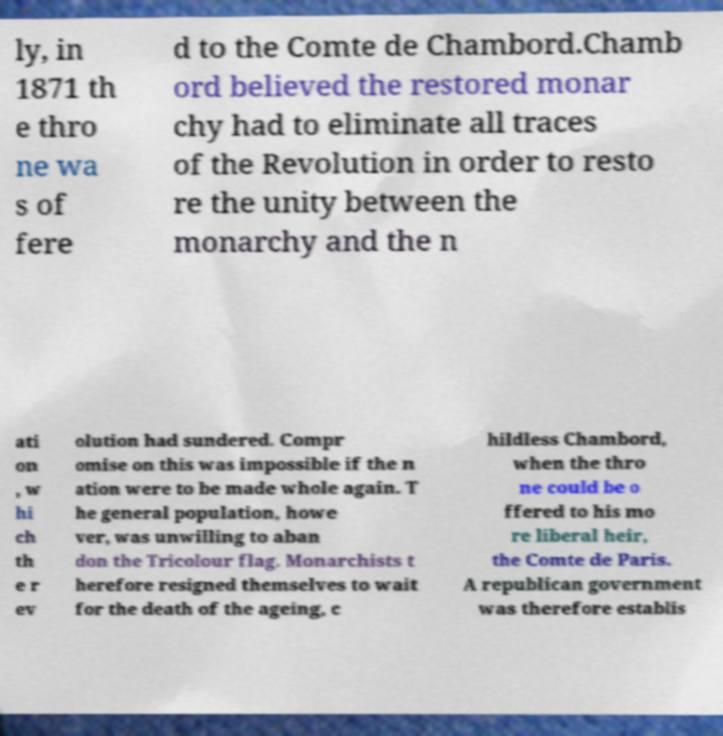There's text embedded in this image that I need extracted. Can you transcribe it verbatim? ly, in 1871 th e thro ne wa s of fere d to the Comte de Chambord.Chamb ord believed the restored monar chy had to eliminate all traces of the Revolution in order to resto re the unity between the monarchy and the n ati on , w hi ch th e r ev olution had sundered. Compr omise on this was impossible if the n ation were to be made whole again. T he general population, howe ver, was unwilling to aban don the Tricolour flag. Monarchists t herefore resigned themselves to wait for the death of the ageing, c hildless Chambord, when the thro ne could be o ffered to his mo re liberal heir, the Comte de Paris. A republican government was therefore establis 